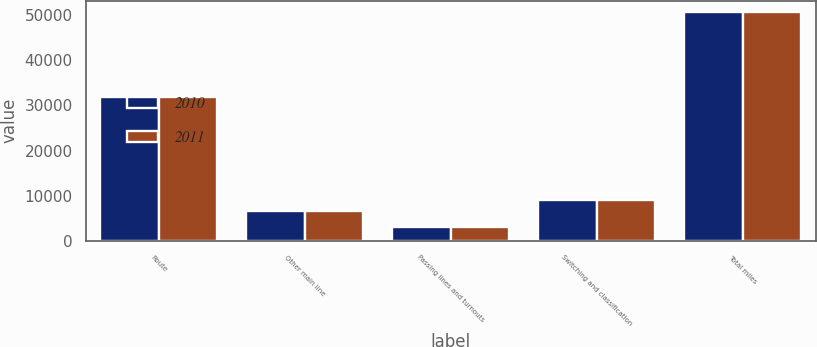<chart> <loc_0><loc_0><loc_500><loc_500><stacked_bar_chart><ecel><fcel>Route<fcel>Other main line<fcel>Passing lines and turnouts<fcel>Switching and classification<fcel>Total miles<nl><fcel>2010<fcel>31898<fcel>6644<fcel>3112<fcel>8999<fcel>50653<nl><fcel>2011<fcel>31953<fcel>6596<fcel>3118<fcel>9006<fcel>50673<nl></chart> 